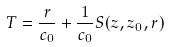<formula> <loc_0><loc_0><loc_500><loc_500>T = \frac { r } { c _ { 0 } } + \frac { 1 } { c _ { 0 } } S ( z , z _ { 0 } , r )</formula> 